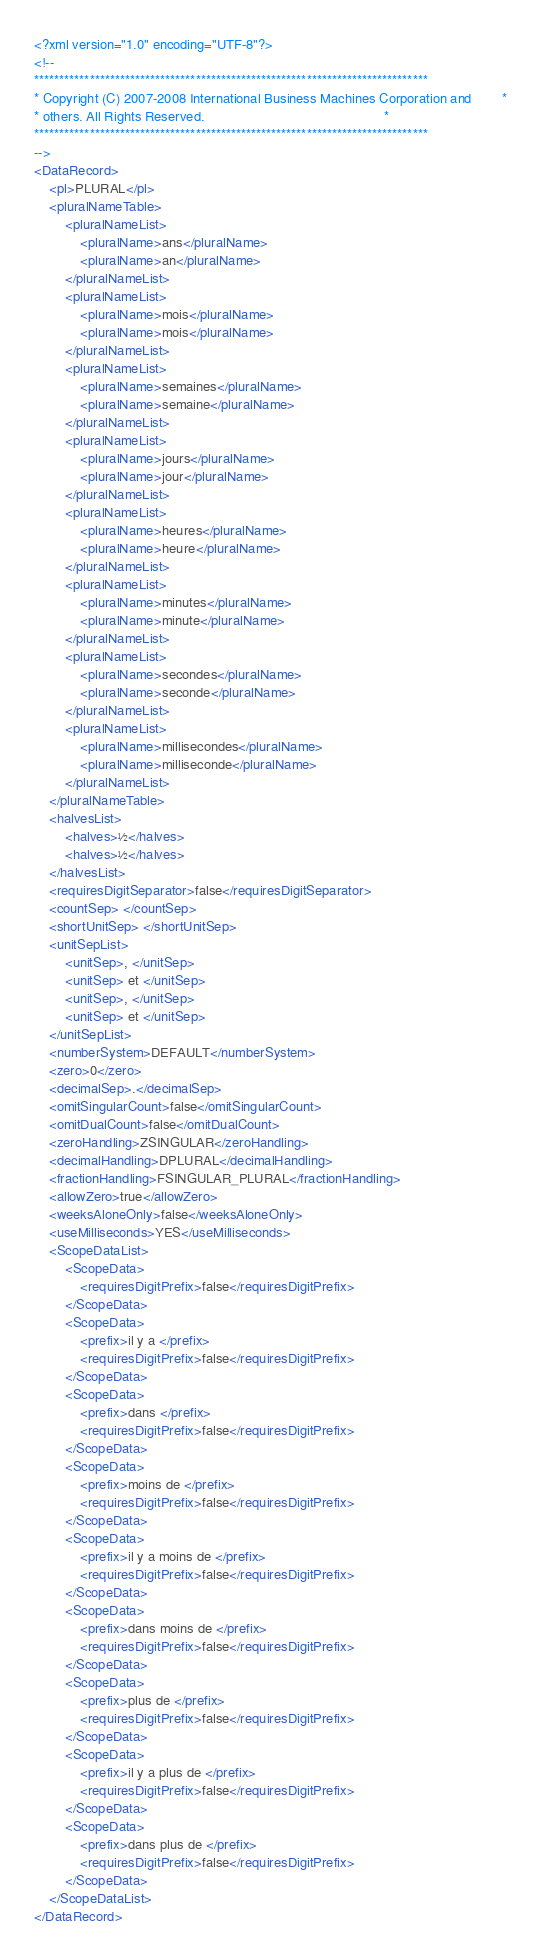<code> <loc_0><loc_0><loc_500><loc_500><_XML_><?xml version="1.0" encoding="UTF-8"?>
<!--
******************************************************************************
* Copyright (C) 2007-2008 International Business Machines Corporation and        *
* others. All Rights Reserved.                                               *
******************************************************************************
-->
<DataRecord>
    <pl>PLURAL</pl>
    <pluralNameTable>
        <pluralNameList>
            <pluralName>ans</pluralName>
            <pluralName>an</pluralName>
        </pluralNameList>
        <pluralNameList>
            <pluralName>mois</pluralName>
            <pluralName>mois</pluralName>
        </pluralNameList>
        <pluralNameList>
            <pluralName>semaines</pluralName>
            <pluralName>semaine</pluralName>
        </pluralNameList>
        <pluralNameList>
            <pluralName>jours</pluralName>
            <pluralName>jour</pluralName>
        </pluralNameList>
        <pluralNameList>
            <pluralName>heures</pluralName>
            <pluralName>heure</pluralName>
        </pluralNameList>
        <pluralNameList>
            <pluralName>minutes</pluralName>
            <pluralName>minute</pluralName>
        </pluralNameList>
        <pluralNameList>
            <pluralName>secondes</pluralName>
            <pluralName>seconde</pluralName>
        </pluralNameList>
        <pluralNameList>
            <pluralName>millisecondes</pluralName>
            <pluralName>milliseconde</pluralName>
        </pluralNameList>
    </pluralNameTable>
    <halvesList>
        <halves>½</halves>
        <halves>½</halves>
    </halvesList>
    <requiresDigitSeparator>false</requiresDigitSeparator>
    <countSep> </countSep>
    <shortUnitSep> </shortUnitSep>
    <unitSepList>
        <unitSep>, </unitSep>
        <unitSep> et </unitSep>
        <unitSep>, </unitSep>
        <unitSep> et </unitSep>
    </unitSepList>
    <numberSystem>DEFAULT</numberSystem>
    <zero>0</zero>
    <decimalSep>.</decimalSep>
    <omitSingularCount>false</omitSingularCount>
    <omitDualCount>false</omitDualCount>
    <zeroHandling>ZSINGULAR</zeroHandling>
    <decimalHandling>DPLURAL</decimalHandling>
    <fractionHandling>FSINGULAR_PLURAL</fractionHandling>
    <allowZero>true</allowZero>
    <weeksAloneOnly>false</weeksAloneOnly>
    <useMilliseconds>YES</useMilliseconds>
    <ScopeDataList>
        <ScopeData>
            <requiresDigitPrefix>false</requiresDigitPrefix>
        </ScopeData>
        <ScopeData>
            <prefix>il y a </prefix>
            <requiresDigitPrefix>false</requiresDigitPrefix>
        </ScopeData>
        <ScopeData>
            <prefix>dans </prefix>
            <requiresDigitPrefix>false</requiresDigitPrefix>
        </ScopeData>
        <ScopeData>
            <prefix>moins de </prefix>
            <requiresDigitPrefix>false</requiresDigitPrefix>
        </ScopeData>
        <ScopeData>
            <prefix>il y a moins de </prefix>
            <requiresDigitPrefix>false</requiresDigitPrefix>
        </ScopeData>
        <ScopeData>
            <prefix>dans moins de </prefix>
            <requiresDigitPrefix>false</requiresDigitPrefix>
        </ScopeData>
        <ScopeData>
            <prefix>plus de </prefix>
            <requiresDigitPrefix>false</requiresDigitPrefix>
        </ScopeData>
        <ScopeData>
            <prefix>il y a plus de </prefix>
            <requiresDigitPrefix>false</requiresDigitPrefix>
        </ScopeData>
        <ScopeData>
            <prefix>dans plus de </prefix>
            <requiresDigitPrefix>false</requiresDigitPrefix>
        </ScopeData>
    </ScopeDataList>
</DataRecord>
</code> 